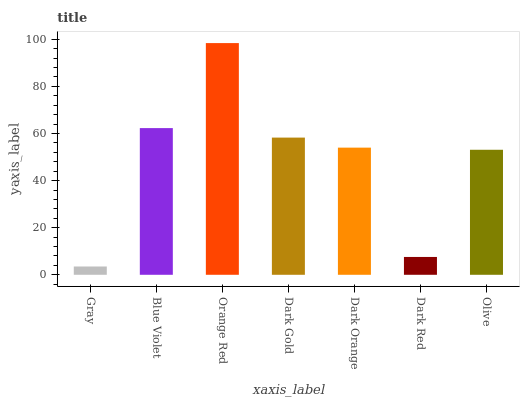Is Gray the minimum?
Answer yes or no. Yes. Is Orange Red the maximum?
Answer yes or no. Yes. Is Blue Violet the minimum?
Answer yes or no. No. Is Blue Violet the maximum?
Answer yes or no. No. Is Blue Violet greater than Gray?
Answer yes or no. Yes. Is Gray less than Blue Violet?
Answer yes or no. Yes. Is Gray greater than Blue Violet?
Answer yes or no. No. Is Blue Violet less than Gray?
Answer yes or no. No. Is Dark Orange the high median?
Answer yes or no. Yes. Is Dark Orange the low median?
Answer yes or no. Yes. Is Dark Gold the high median?
Answer yes or no. No. Is Dark Gold the low median?
Answer yes or no. No. 